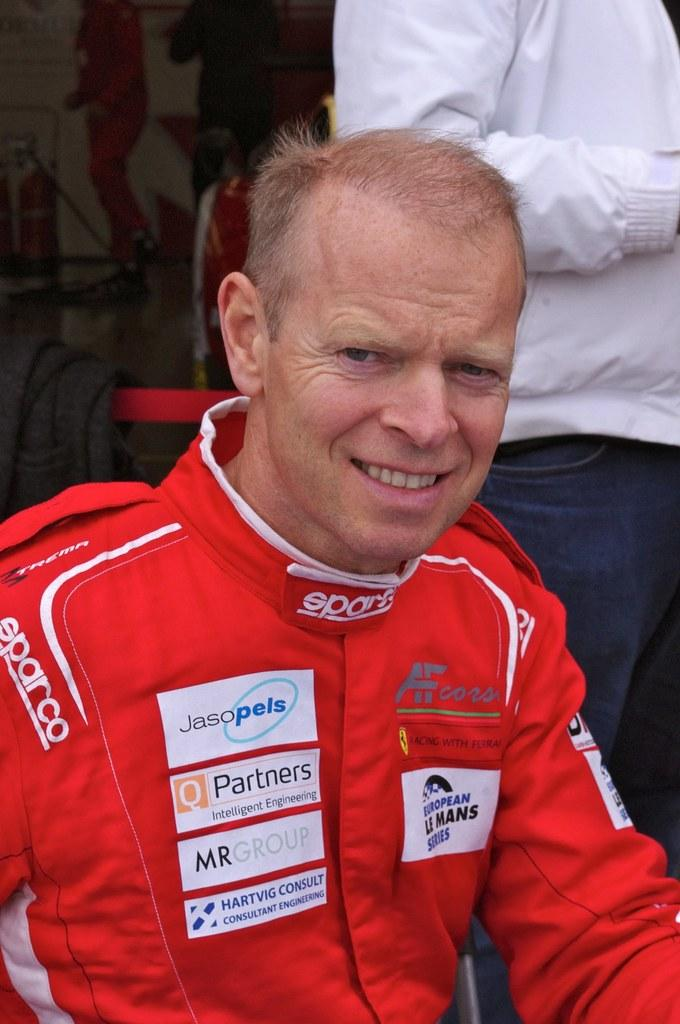<image>
Write a terse but informative summary of the picture. A man in a orange sparco jumpsuit covered in sponsors. 